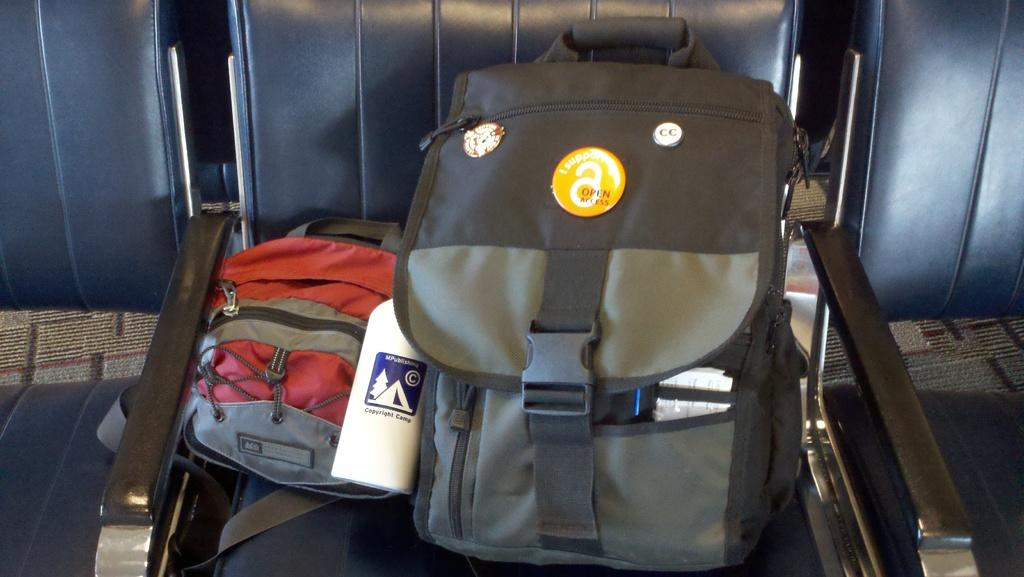What objects are on the chair in the image? There are two bags on a chair in the image. How many chairs are visible in the image? There are three chairs in the image. What type of teeth can be seen on the donkey in the image? There is no donkey present in the image, and therefore no teeth can be observed. 